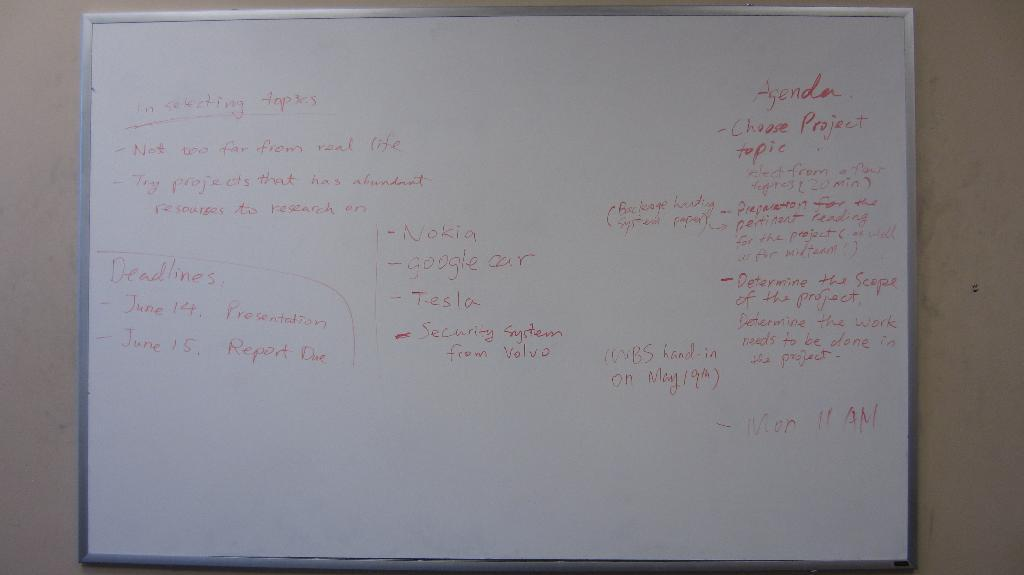Provide a one-sentence caption for the provided image. A white board with information on selecting a topic for a report. 